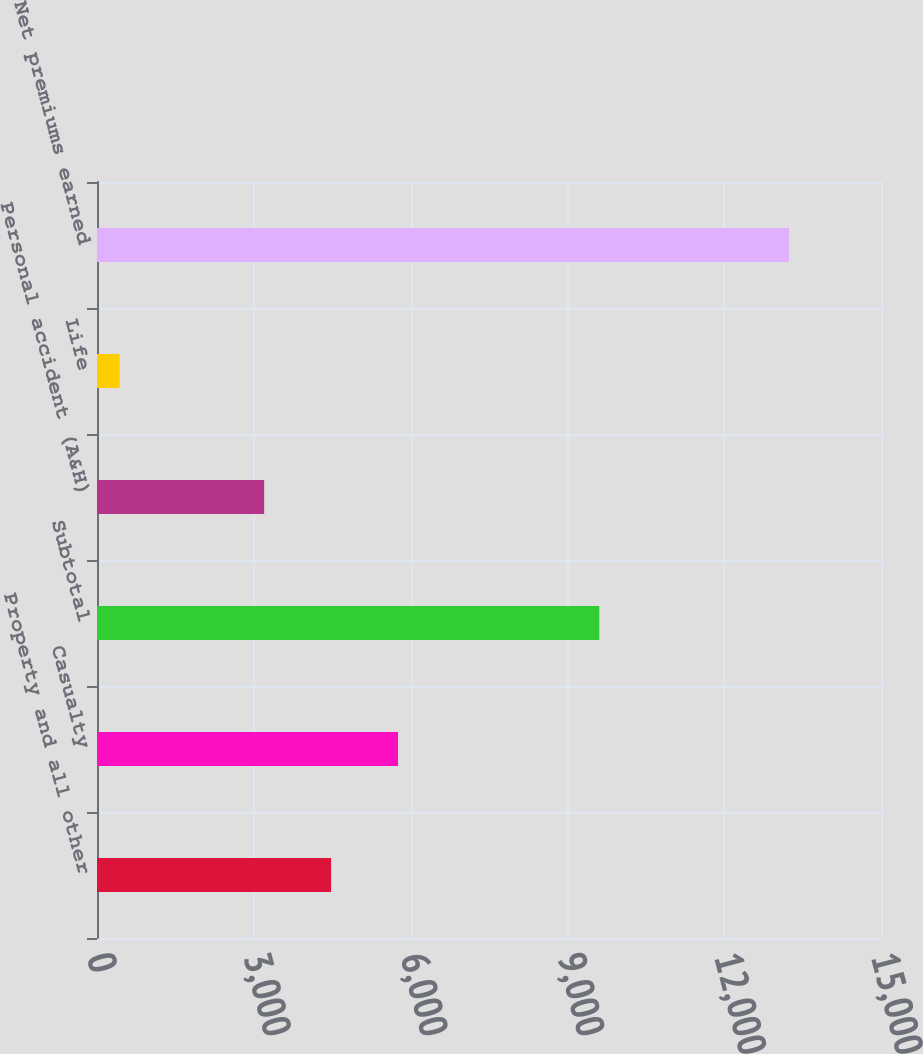Convert chart to OTSL. <chart><loc_0><loc_0><loc_500><loc_500><bar_chart><fcel>Property and all other<fcel>Casualty<fcel>Subtotal<fcel>Personal accident (A&H)<fcel>Life<fcel>Net premiums earned<nl><fcel>4478.8<fcel>5759.6<fcel>9610<fcel>3198<fcel>432<fcel>13240<nl></chart> 